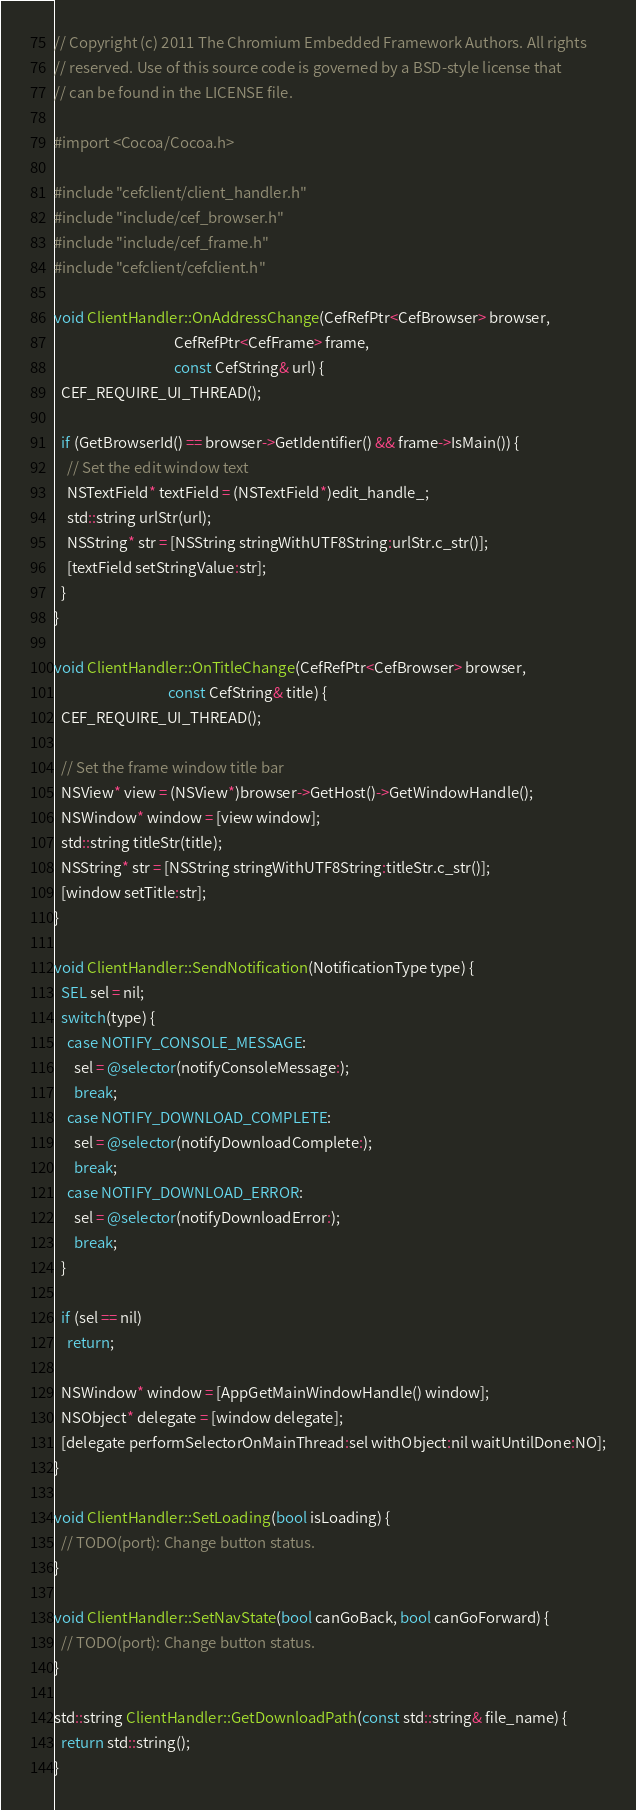Convert code to text. <code><loc_0><loc_0><loc_500><loc_500><_ObjectiveC_>// Copyright (c) 2011 The Chromium Embedded Framework Authors. All rights
// reserved. Use of this source code is governed by a BSD-style license that
// can be found in the LICENSE file.

#import <Cocoa/Cocoa.h>

#include "cefclient/client_handler.h"
#include "include/cef_browser.h"
#include "include/cef_frame.h"
#include "cefclient/cefclient.h"

void ClientHandler::OnAddressChange(CefRefPtr<CefBrowser> browser,
                                    CefRefPtr<CefFrame> frame,
                                    const CefString& url) {
  CEF_REQUIRE_UI_THREAD();

  if (GetBrowserId() == browser->GetIdentifier() && frame->IsMain()) {
    // Set the edit window text
    NSTextField* textField = (NSTextField*)edit_handle_;
    std::string urlStr(url);
    NSString* str = [NSString stringWithUTF8String:urlStr.c_str()];
    [textField setStringValue:str];
  }
}

void ClientHandler::OnTitleChange(CefRefPtr<CefBrowser> browser,
                                  const CefString& title) {
  CEF_REQUIRE_UI_THREAD();

  // Set the frame window title bar
  NSView* view = (NSView*)browser->GetHost()->GetWindowHandle();
  NSWindow* window = [view window];
  std::string titleStr(title);
  NSString* str = [NSString stringWithUTF8String:titleStr.c_str()];
  [window setTitle:str];
}

void ClientHandler::SendNotification(NotificationType type) {
  SEL sel = nil;
  switch(type) {
    case NOTIFY_CONSOLE_MESSAGE:
      sel = @selector(notifyConsoleMessage:);
      break;
    case NOTIFY_DOWNLOAD_COMPLETE:
      sel = @selector(notifyDownloadComplete:);
      break;
    case NOTIFY_DOWNLOAD_ERROR:
      sel = @selector(notifyDownloadError:);
      break;
  }

  if (sel == nil)
    return;

  NSWindow* window = [AppGetMainWindowHandle() window];
  NSObject* delegate = [window delegate];
  [delegate performSelectorOnMainThread:sel withObject:nil waitUntilDone:NO];
}

void ClientHandler::SetLoading(bool isLoading) {
  // TODO(port): Change button status.
}

void ClientHandler::SetNavState(bool canGoBack, bool canGoForward) {
  // TODO(port): Change button status.
}

std::string ClientHandler::GetDownloadPath(const std::string& file_name) {
  return std::string();
}
</code> 